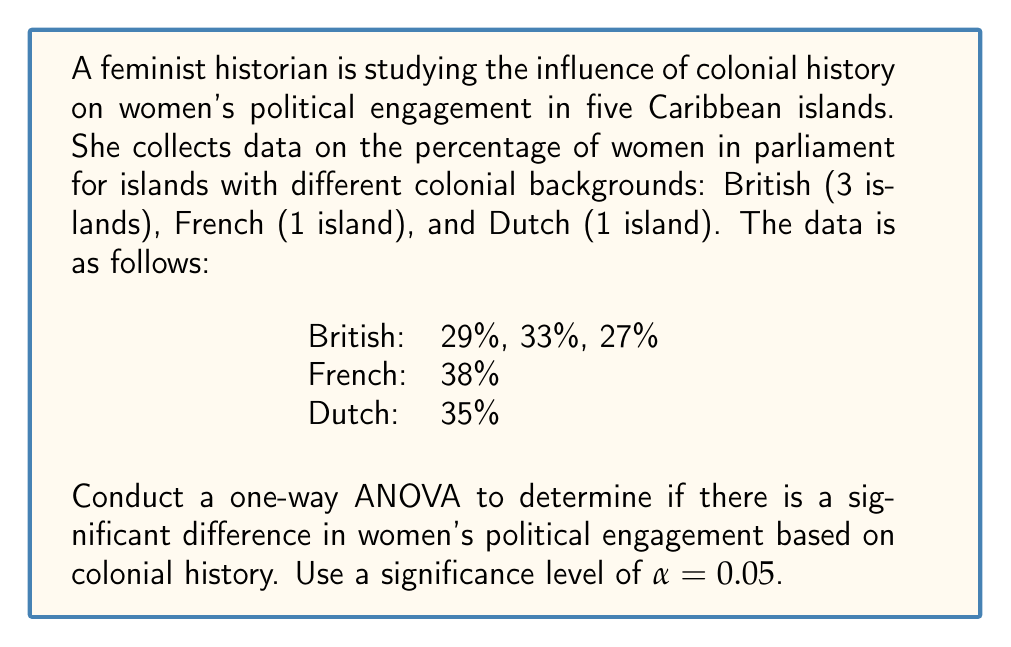Teach me how to tackle this problem. To conduct a one-way ANOVA, we'll follow these steps:

1. Calculate the sum of squares between groups (SSB) and within groups (SSW).
2. Calculate the degrees of freedom for between groups (dfB) and within groups (dfW).
3. Calculate the mean square between groups (MSB) and within groups (MSW).
4. Calculate the F-statistic.
5. Compare the F-statistic to the critical F-value.

Step 1: Calculate SSB and SSW

First, we need to calculate the grand mean:
$$ \bar{X} = \frac{29 + 33 + 27 + 38 + 35}{5} = 32.4 $$

Now, calculate SSB:
$$ SSB = n_1(\bar{X}_1 - \bar{X})^2 + n_2(\bar{X}_2 - \bar{X})^2 + n_3(\bar{X}_3 - \bar{X})^2 $$
Where $n_1 = 3$, $n_2 = 1$, $n_3 = 1$, $\bar{X}_1 = 29.67$, $\bar{X}_2 = 38$, $\bar{X}_3 = 35$

$$ SSB = 3(29.67 - 32.4)^2 + 1(38 - 32.4)^2 + 1(35 - 32.4)^2 = 50.13 $$

For SSW, calculate the sum of squared deviations within each group:
$$ SSW = \sum_{i=1}^{3} (X_i - 29.67)^2 + (38 - 38)^2 + (35 - 35)^2 = 18.67 $$

Step 2: Calculate degrees of freedom

$$ df_B = k - 1 = 3 - 1 = 2 $$
$$ df_W = N - k = 5 - 3 = 2 $$

Where k is the number of groups and N is the total sample size.

Step 3: Calculate MSB and MSW

$$ MSB = \frac{SSB}{df_B} = \frac{50.13}{2} = 25.065 $$
$$ MSW = \frac{SSW}{df_W} = \frac{18.67}{2} = 9.335 $$

Step 4: Calculate F-statistic

$$ F = \frac{MSB}{MSW} = \frac{25.065}{9.335} = 2.685 $$

Step 5: Compare F-statistic to critical F-value

The critical F-value for α = 0.05, dfB = 2, and dfW = 2 is 19.00.

Since the calculated F-statistic (2.685) is less than the critical F-value (19.00), we fail to reject the null hypothesis.
Answer: F(2, 2) = 2.685, p > 0.05. There is no significant difference in women's political engagement based on colonial history at the 0.05 significance level. 